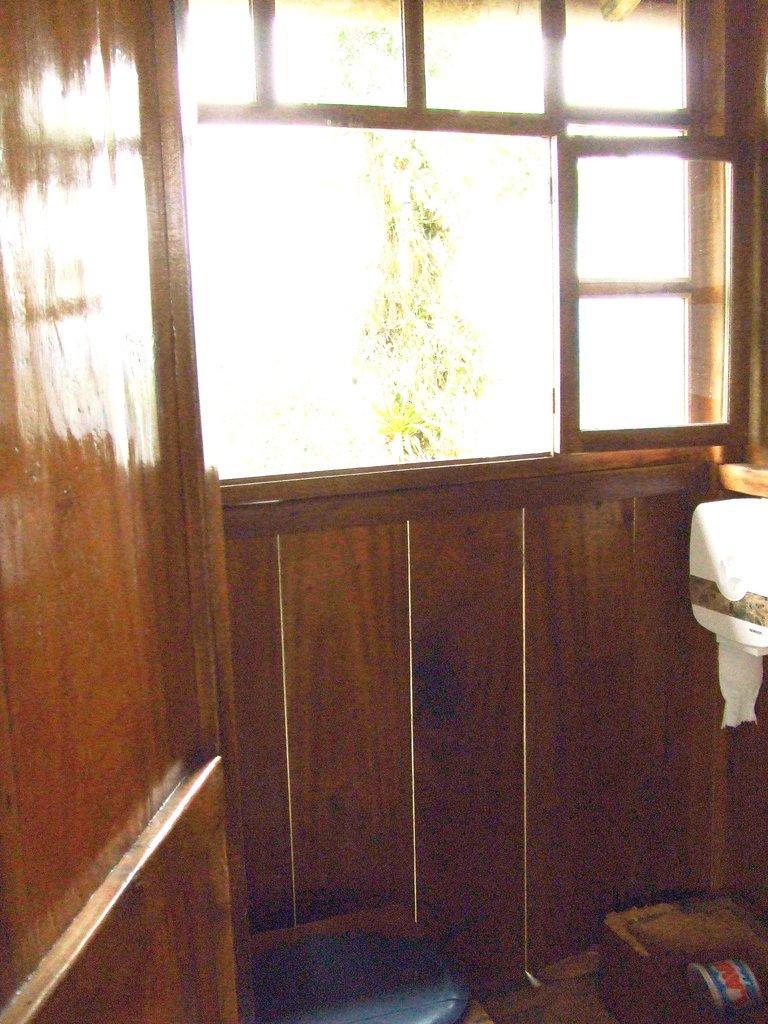Please provide a concise description of this image. In this picture we can see a wall, window, and a tissue box. And there are some objects on the floor. 